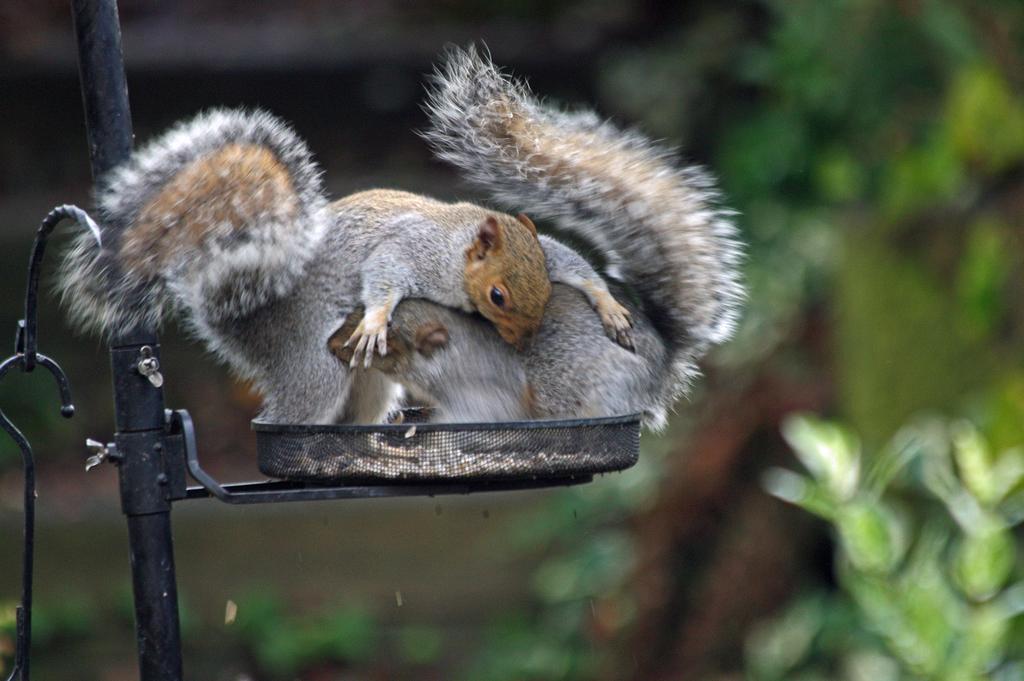How would you summarize this image in a sentence or two? This picture contains two squirrels. Beside that, we see a black color pole. At the bottom of the picture, we see trees and plants. In the background, it is in green and black color and it is blurred in the background. 